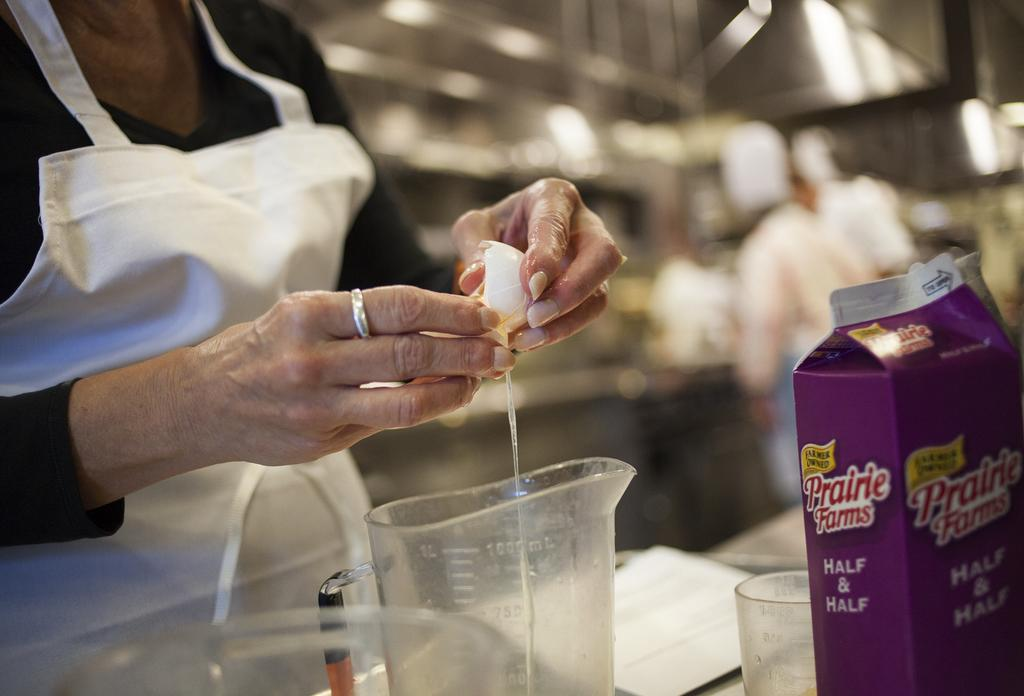Provide a one-sentence caption for the provided image. A person cracking an egg into a container with a carton of Prairie Farms half and half nearby. 